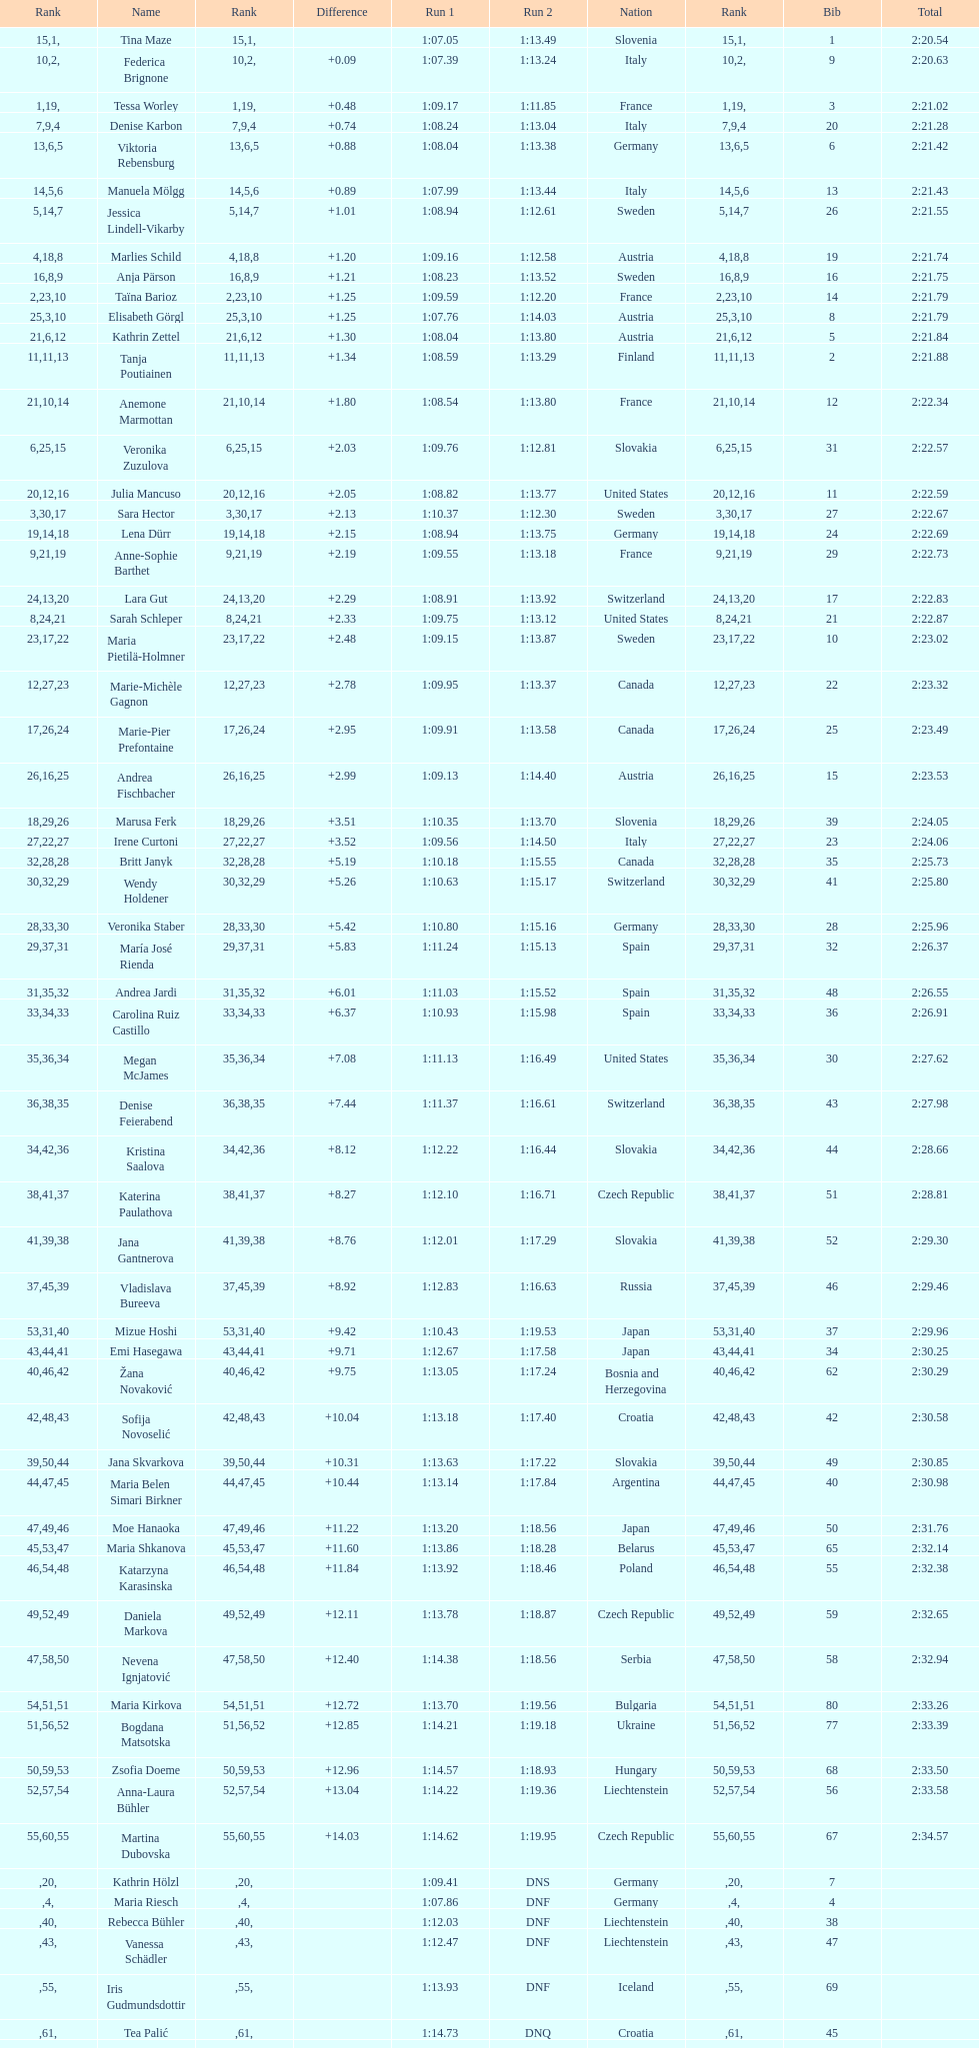What is the last nation to be ranked? Czech Republic. 